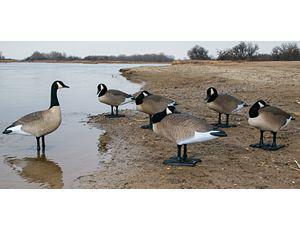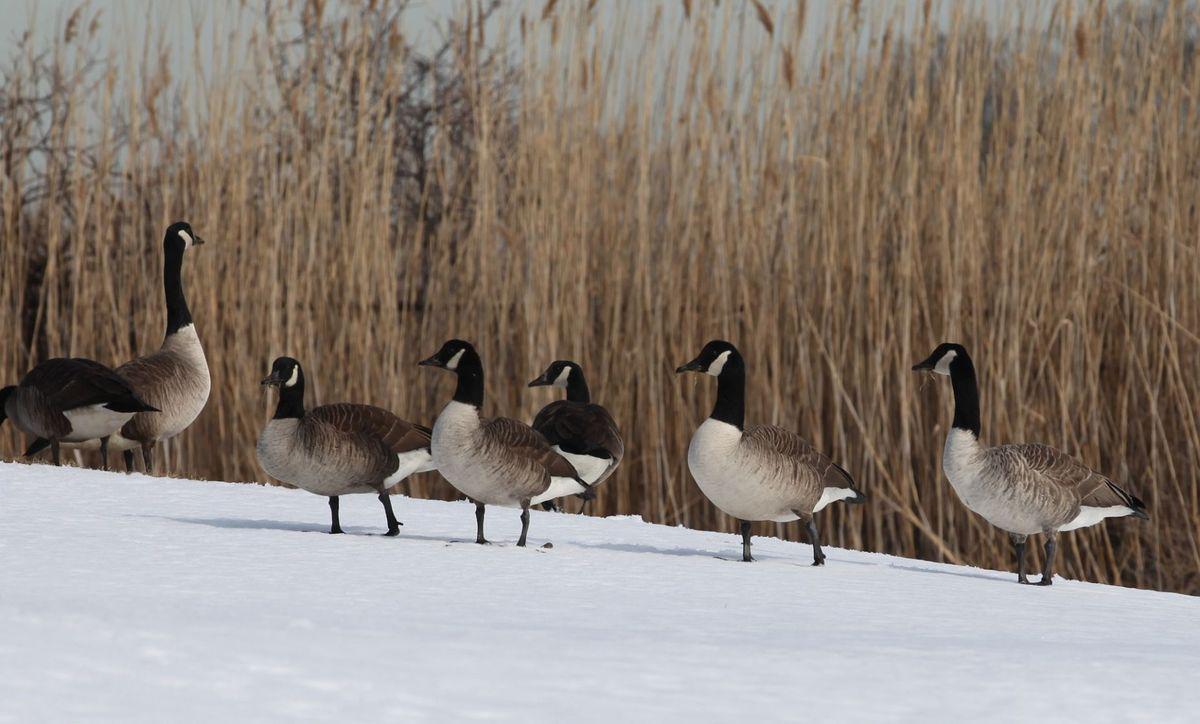The first image is the image on the left, the second image is the image on the right. Given the left and right images, does the statement "All birds are standing, and all birds are 'real' living animals." hold true? Answer yes or no. Yes. The first image is the image on the left, the second image is the image on the right. Given the left and right images, does the statement "None of the birds are standing on wood or snow." hold true? Answer yes or no. No. 